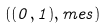Convert formula to latex. <formula><loc_0><loc_0><loc_500><loc_500>( ( 0 , 1 ) , m e s )</formula> 